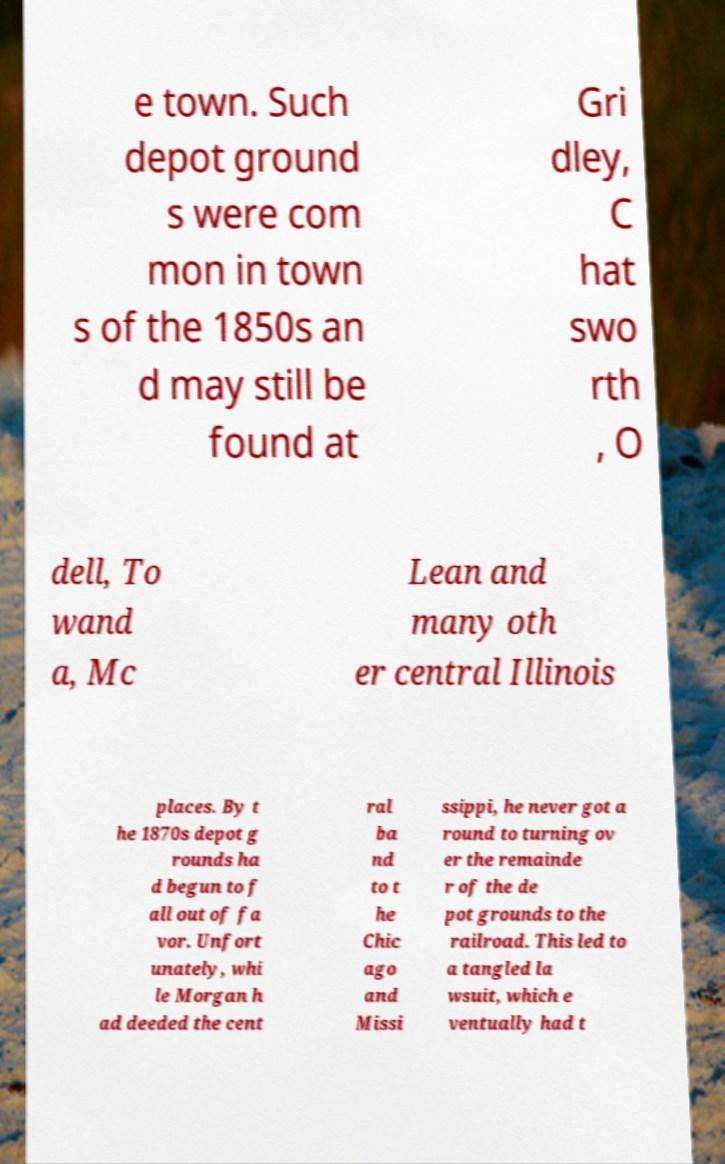Can you accurately transcribe the text from the provided image for me? e town. Such depot ground s were com mon in town s of the 1850s an d may still be found at Gri dley, C hat swo rth , O dell, To wand a, Mc Lean and many oth er central Illinois places. By t he 1870s depot g rounds ha d begun to f all out of fa vor. Unfort unately, whi le Morgan h ad deeded the cent ral ba nd to t he Chic ago and Missi ssippi, he never got a round to turning ov er the remainde r of the de pot grounds to the railroad. This led to a tangled la wsuit, which e ventually had t 